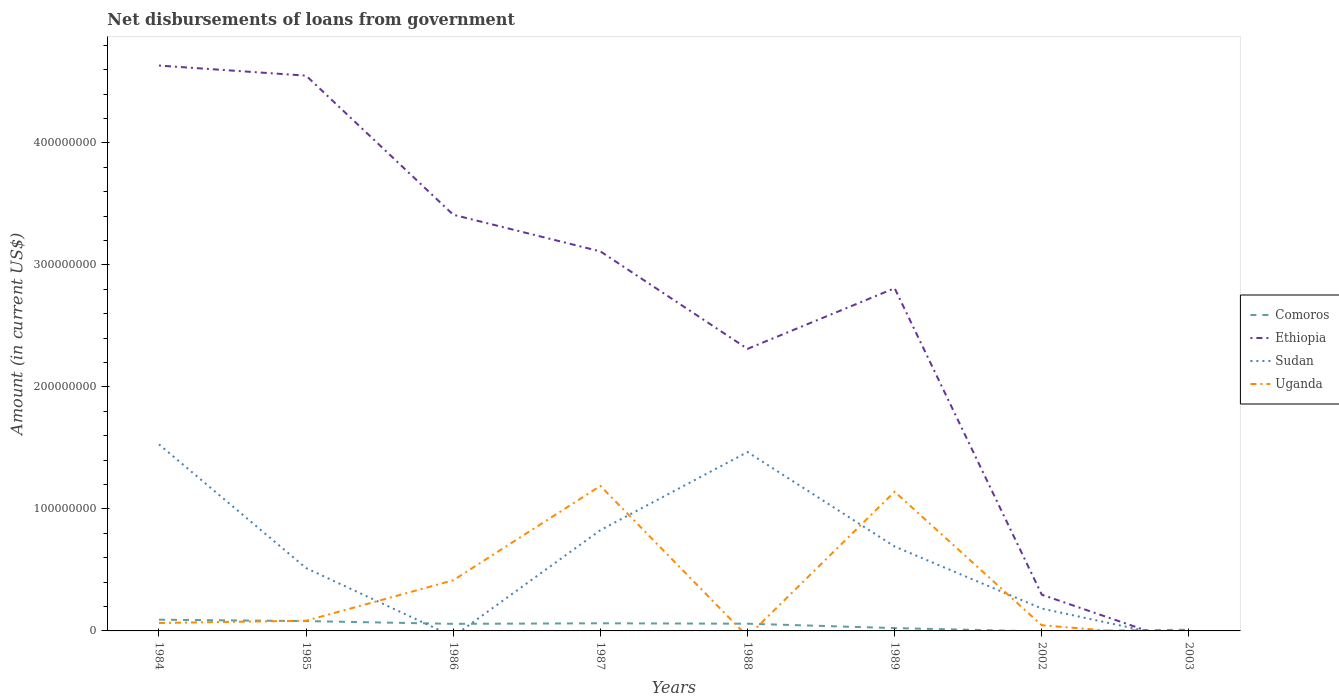Does the line corresponding to Uganda intersect with the line corresponding to Ethiopia?
Offer a terse response. Yes. Across all years, what is the maximum amount of loan disbursed from government in Comoros?
Your answer should be compact. 0. What is the total amount of loan disbursed from government in Ethiopia in the graph?
Offer a terse response. 1.74e+08. What is the difference between the highest and the second highest amount of loan disbursed from government in Comoros?
Provide a succinct answer. 9.22e+06. Is the amount of loan disbursed from government in Sudan strictly greater than the amount of loan disbursed from government in Uganda over the years?
Your response must be concise. No. How many lines are there?
Provide a short and direct response. 4. How are the legend labels stacked?
Your answer should be compact. Vertical. What is the title of the graph?
Provide a short and direct response. Net disbursements of loans from government. Does "Burkina Faso" appear as one of the legend labels in the graph?
Provide a succinct answer. No. What is the label or title of the Y-axis?
Ensure brevity in your answer.  Amount (in current US$). What is the Amount (in current US$) of Comoros in 1984?
Your answer should be compact. 9.22e+06. What is the Amount (in current US$) in Ethiopia in 1984?
Ensure brevity in your answer.  4.63e+08. What is the Amount (in current US$) in Sudan in 1984?
Provide a succinct answer. 1.53e+08. What is the Amount (in current US$) in Uganda in 1984?
Make the answer very short. 6.49e+06. What is the Amount (in current US$) of Comoros in 1985?
Keep it short and to the point. 8.06e+06. What is the Amount (in current US$) in Ethiopia in 1985?
Your answer should be very brief. 4.55e+08. What is the Amount (in current US$) of Sudan in 1985?
Your response must be concise. 5.15e+07. What is the Amount (in current US$) in Uganda in 1985?
Offer a very short reply. 8.37e+06. What is the Amount (in current US$) in Comoros in 1986?
Your response must be concise. 5.80e+06. What is the Amount (in current US$) of Ethiopia in 1986?
Your answer should be compact. 3.41e+08. What is the Amount (in current US$) of Uganda in 1986?
Offer a very short reply. 4.15e+07. What is the Amount (in current US$) of Comoros in 1987?
Your answer should be compact. 6.25e+06. What is the Amount (in current US$) in Ethiopia in 1987?
Offer a terse response. 3.11e+08. What is the Amount (in current US$) in Sudan in 1987?
Your response must be concise. 8.26e+07. What is the Amount (in current US$) in Uganda in 1987?
Provide a succinct answer. 1.19e+08. What is the Amount (in current US$) of Comoros in 1988?
Your response must be concise. 5.91e+06. What is the Amount (in current US$) of Ethiopia in 1988?
Your answer should be compact. 2.31e+08. What is the Amount (in current US$) of Sudan in 1988?
Provide a succinct answer. 1.47e+08. What is the Amount (in current US$) of Uganda in 1988?
Ensure brevity in your answer.  0. What is the Amount (in current US$) in Comoros in 1989?
Your response must be concise. 2.32e+06. What is the Amount (in current US$) of Ethiopia in 1989?
Your answer should be very brief. 2.81e+08. What is the Amount (in current US$) of Sudan in 1989?
Give a very brief answer. 6.92e+07. What is the Amount (in current US$) in Uganda in 1989?
Your answer should be compact. 1.14e+08. What is the Amount (in current US$) in Ethiopia in 2002?
Offer a terse response. 2.97e+07. What is the Amount (in current US$) in Sudan in 2002?
Ensure brevity in your answer.  1.83e+07. What is the Amount (in current US$) of Uganda in 2002?
Offer a very short reply. 4.65e+06. What is the Amount (in current US$) in Comoros in 2003?
Your answer should be very brief. 9.96e+05. What is the Amount (in current US$) of Ethiopia in 2003?
Offer a terse response. 0. What is the Amount (in current US$) of Uganda in 2003?
Provide a succinct answer. 0. Across all years, what is the maximum Amount (in current US$) in Comoros?
Offer a terse response. 9.22e+06. Across all years, what is the maximum Amount (in current US$) of Ethiopia?
Your answer should be very brief. 4.63e+08. Across all years, what is the maximum Amount (in current US$) in Sudan?
Your answer should be compact. 1.53e+08. Across all years, what is the maximum Amount (in current US$) of Uganda?
Make the answer very short. 1.19e+08. Across all years, what is the minimum Amount (in current US$) in Sudan?
Your response must be concise. 0. What is the total Amount (in current US$) in Comoros in the graph?
Offer a very short reply. 3.86e+07. What is the total Amount (in current US$) of Ethiopia in the graph?
Make the answer very short. 2.11e+09. What is the total Amount (in current US$) in Sudan in the graph?
Offer a very short reply. 5.21e+08. What is the total Amount (in current US$) of Uganda in the graph?
Your answer should be compact. 2.94e+08. What is the difference between the Amount (in current US$) of Comoros in 1984 and that in 1985?
Your response must be concise. 1.16e+06. What is the difference between the Amount (in current US$) in Ethiopia in 1984 and that in 1985?
Provide a short and direct response. 8.29e+06. What is the difference between the Amount (in current US$) of Sudan in 1984 and that in 1985?
Give a very brief answer. 1.01e+08. What is the difference between the Amount (in current US$) in Uganda in 1984 and that in 1985?
Your answer should be compact. -1.88e+06. What is the difference between the Amount (in current US$) of Comoros in 1984 and that in 1986?
Ensure brevity in your answer.  3.42e+06. What is the difference between the Amount (in current US$) of Ethiopia in 1984 and that in 1986?
Your answer should be compact. 1.22e+08. What is the difference between the Amount (in current US$) of Uganda in 1984 and that in 1986?
Ensure brevity in your answer.  -3.50e+07. What is the difference between the Amount (in current US$) of Comoros in 1984 and that in 1987?
Offer a very short reply. 2.97e+06. What is the difference between the Amount (in current US$) of Ethiopia in 1984 and that in 1987?
Offer a very short reply. 1.52e+08. What is the difference between the Amount (in current US$) in Sudan in 1984 and that in 1987?
Offer a very short reply. 7.03e+07. What is the difference between the Amount (in current US$) in Uganda in 1984 and that in 1987?
Provide a succinct answer. -1.12e+08. What is the difference between the Amount (in current US$) of Comoros in 1984 and that in 1988?
Your answer should be very brief. 3.30e+06. What is the difference between the Amount (in current US$) in Ethiopia in 1984 and that in 1988?
Give a very brief answer. 2.32e+08. What is the difference between the Amount (in current US$) of Sudan in 1984 and that in 1988?
Make the answer very short. 6.27e+06. What is the difference between the Amount (in current US$) in Comoros in 1984 and that in 1989?
Offer a very short reply. 6.90e+06. What is the difference between the Amount (in current US$) in Ethiopia in 1984 and that in 1989?
Ensure brevity in your answer.  1.83e+08. What is the difference between the Amount (in current US$) of Sudan in 1984 and that in 1989?
Ensure brevity in your answer.  8.37e+07. What is the difference between the Amount (in current US$) of Uganda in 1984 and that in 1989?
Your answer should be compact. -1.08e+08. What is the difference between the Amount (in current US$) of Ethiopia in 1984 and that in 2002?
Your answer should be very brief. 4.34e+08. What is the difference between the Amount (in current US$) in Sudan in 1984 and that in 2002?
Ensure brevity in your answer.  1.35e+08. What is the difference between the Amount (in current US$) of Uganda in 1984 and that in 2002?
Your response must be concise. 1.84e+06. What is the difference between the Amount (in current US$) of Comoros in 1984 and that in 2003?
Keep it short and to the point. 8.22e+06. What is the difference between the Amount (in current US$) in Comoros in 1985 and that in 1986?
Ensure brevity in your answer.  2.26e+06. What is the difference between the Amount (in current US$) of Ethiopia in 1985 and that in 1986?
Give a very brief answer. 1.14e+08. What is the difference between the Amount (in current US$) in Uganda in 1985 and that in 1986?
Give a very brief answer. -3.31e+07. What is the difference between the Amount (in current US$) of Comoros in 1985 and that in 1987?
Provide a succinct answer. 1.80e+06. What is the difference between the Amount (in current US$) of Ethiopia in 1985 and that in 1987?
Offer a terse response. 1.44e+08. What is the difference between the Amount (in current US$) of Sudan in 1985 and that in 1987?
Keep it short and to the point. -3.11e+07. What is the difference between the Amount (in current US$) in Uganda in 1985 and that in 1987?
Give a very brief answer. -1.10e+08. What is the difference between the Amount (in current US$) of Comoros in 1985 and that in 1988?
Keep it short and to the point. 2.14e+06. What is the difference between the Amount (in current US$) in Ethiopia in 1985 and that in 1988?
Provide a short and direct response. 2.24e+08. What is the difference between the Amount (in current US$) in Sudan in 1985 and that in 1988?
Provide a short and direct response. -9.51e+07. What is the difference between the Amount (in current US$) of Comoros in 1985 and that in 1989?
Give a very brief answer. 5.74e+06. What is the difference between the Amount (in current US$) in Ethiopia in 1985 and that in 1989?
Your answer should be compact. 1.74e+08. What is the difference between the Amount (in current US$) in Sudan in 1985 and that in 1989?
Offer a terse response. -1.77e+07. What is the difference between the Amount (in current US$) in Uganda in 1985 and that in 1989?
Provide a succinct answer. -1.06e+08. What is the difference between the Amount (in current US$) in Ethiopia in 1985 and that in 2002?
Give a very brief answer. 4.25e+08. What is the difference between the Amount (in current US$) of Sudan in 1985 and that in 2002?
Your answer should be very brief. 3.32e+07. What is the difference between the Amount (in current US$) in Uganda in 1985 and that in 2002?
Your answer should be very brief. 3.72e+06. What is the difference between the Amount (in current US$) of Comoros in 1985 and that in 2003?
Offer a terse response. 7.06e+06. What is the difference between the Amount (in current US$) of Comoros in 1986 and that in 1987?
Make the answer very short. -4.54e+05. What is the difference between the Amount (in current US$) in Ethiopia in 1986 and that in 1987?
Ensure brevity in your answer.  3.00e+07. What is the difference between the Amount (in current US$) of Uganda in 1986 and that in 1987?
Make the answer very short. -7.73e+07. What is the difference between the Amount (in current US$) in Comoros in 1986 and that in 1988?
Keep it short and to the point. -1.15e+05. What is the difference between the Amount (in current US$) of Ethiopia in 1986 and that in 1988?
Ensure brevity in your answer.  1.10e+08. What is the difference between the Amount (in current US$) of Comoros in 1986 and that in 1989?
Give a very brief answer. 3.48e+06. What is the difference between the Amount (in current US$) of Ethiopia in 1986 and that in 1989?
Provide a succinct answer. 6.02e+07. What is the difference between the Amount (in current US$) of Uganda in 1986 and that in 1989?
Ensure brevity in your answer.  -7.26e+07. What is the difference between the Amount (in current US$) in Ethiopia in 1986 and that in 2002?
Keep it short and to the point. 3.11e+08. What is the difference between the Amount (in current US$) of Uganda in 1986 and that in 2002?
Your answer should be compact. 3.69e+07. What is the difference between the Amount (in current US$) of Comoros in 1986 and that in 2003?
Provide a short and direct response. 4.80e+06. What is the difference between the Amount (in current US$) of Comoros in 1987 and that in 1988?
Your response must be concise. 3.39e+05. What is the difference between the Amount (in current US$) in Ethiopia in 1987 and that in 1988?
Your response must be concise. 7.99e+07. What is the difference between the Amount (in current US$) in Sudan in 1987 and that in 1988?
Keep it short and to the point. -6.40e+07. What is the difference between the Amount (in current US$) of Comoros in 1987 and that in 1989?
Keep it short and to the point. 3.93e+06. What is the difference between the Amount (in current US$) in Ethiopia in 1987 and that in 1989?
Your response must be concise. 3.02e+07. What is the difference between the Amount (in current US$) in Sudan in 1987 and that in 1989?
Make the answer very short. 1.34e+07. What is the difference between the Amount (in current US$) in Uganda in 1987 and that in 1989?
Offer a very short reply. 4.75e+06. What is the difference between the Amount (in current US$) in Ethiopia in 1987 and that in 2002?
Ensure brevity in your answer.  2.81e+08. What is the difference between the Amount (in current US$) in Sudan in 1987 and that in 2002?
Offer a very short reply. 6.43e+07. What is the difference between the Amount (in current US$) in Uganda in 1987 and that in 2002?
Offer a terse response. 1.14e+08. What is the difference between the Amount (in current US$) of Comoros in 1987 and that in 2003?
Offer a very short reply. 5.26e+06. What is the difference between the Amount (in current US$) in Comoros in 1988 and that in 1989?
Keep it short and to the point. 3.59e+06. What is the difference between the Amount (in current US$) of Ethiopia in 1988 and that in 1989?
Provide a succinct answer. -4.97e+07. What is the difference between the Amount (in current US$) in Sudan in 1988 and that in 1989?
Ensure brevity in your answer.  7.74e+07. What is the difference between the Amount (in current US$) of Ethiopia in 1988 and that in 2002?
Your response must be concise. 2.02e+08. What is the difference between the Amount (in current US$) of Sudan in 1988 and that in 2002?
Keep it short and to the point. 1.28e+08. What is the difference between the Amount (in current US$) of Comoros in 1988 and that in 2003?
Keep it short and to the point. 4.92e+06. What is the difference between the Amount (in current US$) of Ethiopia in 1989 and that in 2002?
Make the answer very short. 2.51e+08. What is the difference between the Amount (in current US$) in Sudan in 1989 and that in 2002?
Give a very brief answer. 5.08e+07. What is the difference between the Amount (in current US$) in Uganda in 1989 and that in 2002?
Offer a terse response. 1.09e+08. What is the difference between the Amount (in current US$) in Comoros in 1989 and that in 2003?
Your answer should be very brief. 1.32e+06. What is the difference between the Amount (in current US$) of Comoros in 1984 and the Amount (in current US$) of Ethiopia in 1985?
Keep it short and to the point. -4.46e+08. What is the difference between the Amount (in current US$) in Comoros in 1984 and the Amount (in current US$) in Sudan in 1985?
Ensure brevity in your answer.  -4.23e+07. What is the difference between the Amount (in current US$) of Comoros in 1984 and the Amount (in current US$) of Uganda in 1985?
Offer a very short reply. 8.48e+05. What is the difference between the Amount (in current US$) in Ethiopia in 1984 and the Amount (in current US$) in Sudan in 1985?
Your answer should be very brief. 4.12e+08. What is the difference between the Amount (in current US$) of Ethiopia in 1984 and the Amount (in current US$) of Uganda in 1985?
Your response must be concise. 4.55e+08. What is the difference between the Amount (in current US$) in Sudan in 1984 and the Amount (in current US$) in Uganda in 1985?
Provide a short and direct response. 1.45e+08. What is the difference between the Amount (in current US$) of Comoros in 1984 and the Amount (in current US$) of Ethiopia in 1986?
Provide a short and direct response. -3.32e+08. What is the difference between the Amount (in current US$) in Comoros in 1984 and the Amount (in current US$) in Uganda in 1986?
Provide a short and direct response. -3.23e+07. What is the difference between the Amount (in current US$) in Ethiopia in 1984 and the Amount (in current US$) in Uganda in 1986?
Your answer should be compact. 4.22e+08. What is the difference between the Amount (in current US$) in Sudan in 1984 and the Amount (in current US$) in Uganda in 1986?
Offer a terse response. 1.11e+08. What is the difference between the Amount (in current US$) of Comoros in 1984 and the Amount (in current US$) of Ethiopia in 1987?
Keep it short and to the point. -3.02e+08. What is the difference between the Amount (in current US$) of Comoros in 1984 and the Amount (in current US$) of Sudan in 1987?
Your answer should be compact. -7.34e+07. What is the difference between the Amount (in current US$) of Comoros in 1984 and the Amount (in current US$) of Uganda in 1987?
Give a very brief answer. -1.10e+08. What is the difference between the Amount (in current US$) in Ethiopia in 1984 and the Amount (in current US$) in Sudan in 1987?
Offer a very short reply. 3.81e+08. What is the difference between the Amount (in current US$) of Ethiopia in 1984 and the Amount (in current US$) of Uganda in 1987?
Offer a terse response. 3.45e+08. What is the difference between the Amount (in current US$) in Sudan in 1984 and the Amount (in current US$) in Uganda in 1987?
Your answer should be compact. 3.41e+07. What is the difference between the Amount (in current US$) in Comoros in 1984 and the Amount (in current US$) in Ethiopia in 1988?
Offer a very short reply. -2.22e+08. What is the difference between the Amount (in current US$) in Comoros in 1984 and the Amount (in current US$) in Sudan in 1988?
Your answer should be very brief. -1.37e+08. What is the difference between the Amount (in current US$) of Ethiopia in 1984 and the Amount (in current US$) of Sudan in 1988?
Keep it short and to the point. 3.17e+08. What is the difference between the Amount (in current US$) of Comoros in 1984 and the Amount (in current US$) of Ethiopia in 1989?
Give a very brief answer. -2.72e+08. What is the difference between the Amount (in current US$) in Comoros in 1984 and the Amount (in current US$) in Sudan in 1989?
Provide a short and direct response. -6.00e+07. What is the difference between the Amount (in current US$) of Comoros in 1984 and the Amount (in current US$) of Uganda in 1989?
Your answer should be very brief. -1.05e+08. What is the difference between the Amount (in current US$) of Ethiopia in 1984 and the Amount (in current US$) of Sudan in 1989?
Keep it short and to the point. 3.94e+08. What is the difference between the Amount (in current US$) of Ethiopia in 1984 and the Amount (in current US$) of Uganda in 1989?
Make the answer very short. 3.49e+08. What is the difference between the Amount (in current US$) of Sudan in 1984 and the Amount (in current US$) of Uganda in 1989?
Provide a succinct answer. 3.88e+07. What is the difference between the Amount (in current US$) of Comoros in 1984 and the Amount (in current US$) of Ethiopia in 2002?
Provide a succinct answer. -2.05e+07. What is the difference between the Amount (in current US$) in Comoros in 1984 and the Amount (in current US$) in Sudan in 2002?
Keep it short and to the point. -9.11e+06. What is the difference between the Amount (in current US$) in Comoros in 1984 and the Amount (in current US$) in Uganda in 2002?
Offer a very short reply. 4.57e+06. What is the difference between the Amount (in current US$) of Ethiopia in 1984 and the Amount (in current US$) of Sudan in 2002?
Provide a short and direct response. 4.45e+08. What is the difference between the Amount (in current US$) in Ethiopia in 1984 and the Amount (in current US$) in Uganda in 2002?
Offer a very short reply. 4.59e+08. What is the difference between the Amount (in current US$) of Sudan in 1984 and the Amount (in current US$) of Uganda in 2002?
Offer a very short reply. 1.48e+08. What is the difference between the Amount (in current US$) of Comoros in 1985 and the Amount (in current US$) of Ethiopia in 1986?
Offer a terse response. -3.33e+08. What is the difference between the Amount (in current US$) of Comoros in 1985 and the Amount (in current US$) of Uganda in 1986?
Your answer should be very brief. -3.35e+07. What is the difference between the Amount (in current US$) in Ethiopia in 1985 and the Amount (in current US$) in Uganda in 1986?
Make the answer very short. 4.14e+08. What is the difference between the Amount (in current US$) in Sudan in 1985 and the Amount (in current US$) in Uganda in 1986?
Offer a very short reply. 9.98e+06. What is the difference between the Amount (in current US$) in Comoros in 1985 and the Amount (in current US$) in Ethiopia in 1987?
Offer a terse response. -3.03e+08. What is the difference between the Amount (in current US$) of Comoros in 1985 and the Amount (in current US$) of Sudan in 1987?
Offer a terse response. -7.45e+07. What is the difference between the Amount (in current US$) of Comoros in 1985 and the Amount (in current US$) of Uganda in 1987?
Ensure brevity in your answer.  -1.11e+08. What is the difference between the Amount (in current US$) in Ethiopia in 1985 and the Amount (in current US$) in Sudan in 1987?
Ensure brevity in your answer.  3.73e+08. What is the difference between the Amount (in current US$) of Ethiopia in 1985 and the Amount (in current US$) of Uganda in 1987?
Your answer should be compact. 3.36e+08. What is the difference between the Amount (in current US$) in Sudan in 1985 and the Amount (in current US$) in Uganda in 1987?
Offer a very short reply. -6.73e+07. What is the difference between the Amount (in current US$) in Comoros in 1985 and the Amount (in current US$) in Ethiopia in 1988?
Your response must be concise. -2.23e+08. What is the difference between the Amount (in current US$) of Comoros in 1985 and the Amount (in current US$) of Sudan in 1988?
Provide a short and direct response. -1.39e+08. What is the difference between the Amount (in current US$) in Ethiopia in 1985 and the Amount (in current US$) in Sudan in 1988?
Your answer should be very brief. 3.08e+08. What is the difference between the Amount (in current US$) of Comoros in 1985 and the Amount (in current US$) of Ethiopia in 1989?
Make the answer very short. -2.73e+08. What is the difference between the Amount (in current US$) in Comoros in 1985 and the Amount (in current US$) in Sudan in 1989?
Offer a terse response. -6.11e+07. What is the difference between the Amount (in current US$) of Comoros in 1985 and the Amount (in current US$) of Uganda in 1989?
Keep it short and to the point. -1.06e+08. What is the difference between the Amount (in current US$) in Ethiopia in 1985 and the Amount (in current US$) in Sudan in 1989?
Offer a terse response. 3.86e+08. What is the difference between the Amount (in current US$) in Ethiopia in 1985 and the Amount (in current US$) in Uganda in 1989?
Ensure brevity in your answer.  3.41e+08. What is the difference between the Amount (in current US$) in Sudan in 1985 and the Amount (in current US$) in Uganda in 1989?
Provide a short and direct response. -6.26e+07. What is the difference between the Amount (in current US$) in Comoros in 1985 and the Amount (in current US$) in Ethiopia in 2002?
Make the answer very short. -2.16e+07. What is the difference between the Amount (in current US$) in Comoros in 1985 and the Amount (in current US$) in Sudan in 2002?
Provide a short and direct response. -1.03e+07. What is the difference between the Amount (in current US$) of Comoros in 1985 and the Amount (in current US$) of Uganda in 2002?
Your answer should be very brief. 3.41e+06. What is the difference between the Amount (in current US$) in Ethiopia in 1985 and the Amount (in current US$) in Sudan in 2002?
Your response must be concise. 4.37e+08. What is the difference between the Amount (in current US$) in Ethiopia in 1985 and the Amount (in current US$) in Uganda in 2002?
Make the answer very short. 4.50e+08. What is the difference between the Amount (in current US$) of Sudan in 1985 and the Amount (in current US$) of Uganda in 2002?
Offer a very short reply. 4.68e+07. What is the difference between the Amount (in current US$) in Comoros in 1986 and the Amount (in current US$) in Ethiopia in 1987?
Your response must be concise. -3.05e+08. What is the difference between the Amount (in current US$) in Comoros in 1986 and the Amount (in current US$) in Sudan in 1987?
Your answer should be very brief. -7.68e+07. What is the difference between the Amount (in current US$) in Comoros in 1986 and the Amount (in current US$) in Uganda in 1987?
Provide a short and direct response. -1.13e+08. What is the difference between the Amount (in current US$) in Ethiopia in 1986 and the Amount (in current US$) in Sudan in 1987?
Your response must be concise. 2.59e+08. What is the difference between the Amount (in current US$) in Ethiopia in 1986 and the Amount (in current US$) in Uganda in 1987?
Make the answer very short. 2.22e+08. What is the difference between the Amount (in current US$) of Comoros in 1986 and the Amount (in current US$) of Ethiopia in 1988?
Give a very brief answer. -2.25e+08. What is the difference between the Amount (in current US$) of Comoros in 1986 and the Amount (in current US$) of Sudan in 1988?
Your response must be concise. -1.41e+08. What is the difference between the Amount (in current US$) of Ethiopia in 1986 and the Amount (in current US$) of Sudan in 1988?
Offer a terse response. 1.94e+08. What is the difference between the Amount (in current US$) of Comoros in 1986 and the Amount (in current US$) of Ethiopia in 1989?
Your answer should be very brief. -2.75e+08. What is the difference between the Amount (in current US$) in Comoros in 1986 and the Amount (in current US$) in Sudan in 1989?
Make the answer very short. -6.34e+07. What is the difference between the Amount (in current US$) in Comoros in 1986 and the Amount (in current US$) in Uganda in 1989?
Keep it short and to the point. -1.08e+08. What is the difference between the Amount (in current US$) of Ethiopia in 1986 and the Amount (in current US$) of Sudan in 1989?
Make the answer very short. 2.72e+08. What is the difference between the Amount (in current US$) in Ethiopia in 1986 and the Amount (in current US$) in Uganda in 1989?
Your answer should be very brief. 2.27e+08. What is the difference between the Amount (in current US$) in Comoros in 1986 and the Amount (in current US$) in Ethiopia in 2002?
Your answer should be very brief. -2.39e+07. What is the difference between the Amount (in current US$) of Comoros in 1986 and the Amount (in current US$) of Sudan in 2002?
Keep it short and to the point. -1.25e+07. What is the difference between the Amount (in current US$) of Comoros in 1986 and the Amount (in current US$) of Uganda in 2002?
Offer a terse response. 1.15e+06. What is the difference between the Amount (in current US$) in Ethiopia in 1986 and the Amount (in current US$) in Sudan in 2002?
Keep it short and to the point. 3.23e+08. What is the difference between the Amount (in current US$) in Ethiopia in 1986 and the Amount (in current US$) in Uganda in 2002?
Your response must be concise. 3.36e+08. What is the difference between the Amount (in current US$) in Comoros in 1987 and the Amount (in current US$) in Ethiopia in 1988?
Your answer should be compact. -2.25e+08. What is the difference between the Amount (in current US$) of Comoros in 1987 and the Amount (in current US$) of Sudan in 1988?
Provide a succinct answer. -1.40e+08. What is the difference between the Amount (in current US$) in Ethiopia in 1987 and the Amount (in current US$) in Sudan in 1988?
Your answer should be very brief. 1.64e+08. What is the difference between the Amount (in current US$) of Comoros in 1987 and the Amount (in current US$) of Ethiopia in 1989?
Your answer should be very brief. -2.75e+08. What is the difference between the Amount (in current US$) in Comoros in 1987 and the Amount (in current US$) in Sudan in 1989?
Ensure brevity in your answer.  -6.29e+07. What is the difference between the Amount (in current US$) in Comoros in 1987 and the Amount (in current US$) in Uganda in 1989?
Offer a terse response. -1.08e+08. What is the difference between the Amount (in current US$) in Ethiopia in 1987 and the Amount (in current US$) in Sudan in 1989?
Your answer should be compact. 2.42e+08. What is the difference between the Amount (in current US$) of Ethiopia in 1987 and the Amount (in current US$) of Uganda in 1989?
Your answer should be compact. 1.97e+08. What is the difference between the Amount (in current US$) in Sudan in 1987 and the Amount (in current US$) in Uganda in 1989?
Your response must be concise. -3.15e+07. What is the difference between the Amount (in current US$) of Comoros in 1987 and the Amount (in current US$) of Ethiopia in 2002?
Your answer should be very brief. -2.34e+07. What is the difference between the Amount (in current US$) in Comoros in 1987 and the Amount (in current US$) in Sudan in 2002?
Make the answer very short. -1.21e+07. What is the difference between the Amount (in current US$) in Comoros in 1987 and the Amount (in current US$) in Uganda in 2002?
Give a very brief answer. 1.60e+06. What is the difference between the Amount (in current US$) in Ethiopia in 1987 and the Amount (in current US$) in Sudan in 2002?
Offer a very short reply. 2.93e+08. What is the difference between the Amount (in current US$) in Ethiopia in 1987 and the Amount (in current US$) in Uganda in 2002?
Make the answer very short. 3.06e+08. What is the difference between the Amount (in current US$) in Sudan in 1987 and the Amount (in current US$) in Uganda in 2002?
Your answer should be very brief. 7.79e+07. What is the difference between the Amount (in current US$) in Comoros in 1988 and the Amount (in current US$) in Ethiopia in 1989?
Make the answer very short. -2.75e+08. What is the difference between the Amount (in current US$) of Comoros in 1988 and the Amount (in current US$) of Sudan in 1989?
Keep it short and to the point. -6.33e+07. What is the difference between the Amount (in current US$) in Comoros in 1988 and the Amount (in current US$) in Uganda in 1989?
Provide a short and direct response. -1.08e+08. What is the difference between the Amount (in current US$) in Ethiopia in 1988 and the Amount (in current US$) in Sudan in 1989?
Provide a short and direct response. 1.62e+08. What is the difference between the Amount (in current US$) of Ethiopia in 1988 and the Amount (in current US$) of Uganda in 1989?
Keep it short and to the point. 1.17e+08. What is the difference between the Amount (in current US$) of Sudan in 1988 and the Amount (in current US$) of Uganda in 1989?
Keep it short and to the point. 3.25e+07. What is the difference between the Amount (in current US$) of Comoros in 1988 and the Amount (in current US$) of Ethiopia in 2002?
Give a very brief answer. -2.38e+07. What is the difference between the Amount (in current US$) of Comoros in 1988 and the Amount (in current US$) of Sudan in 2002?
Keep it short and to the point. -1.24e+07. What is the difference between the Amount (in current US$) of Comoros in 1988 and the Amount (in current US$) of Uganda in 2002?
Give a very brief answer. 1.26e+06. What is the difference between the Amount (in current US$) of Ethiopia in 1988 and the Amount (in current US$) of Sudan in 2002?
Your answer should be compact. 2.13e+08. What is the difference between the Amount (in current US$) in Ethiopia in 1988 and the Amount (in current US$) in Uganda in 2002?
Your answer should be very brief. 2.27e+08. What is the difference between the Amount (in current US$) in Sudan in 1988 and the Amount (in current US$) in Uganda in 2002?
Ensure brevity in your answer.  1.42e+08. What is the difference between the Amount (in current US$) in Comoros in 1989 and the Amount (in current US$) in Ethiopia in 2002?
Offer a terse response. -2.74e+07. What is the difference between the Amount (in current US$) in Comoros in 1989 and the Amount (in current US$) in Sudan in 2002?
Your answer should be very brief. -1.60e+07. What is the difference between the Amount (in current US$) in Comoros in 1989 and the Amount (in current US$) in Uganda in 2002?
Give a very brief answer. -2.33e+06. What is the difference between the Amount (in current US$) in Ethiopia in 1989 and the Amount (in current US$) in Sudan in 2002?
Offer a terse response. 2.63e+08. What is the difference between the Amount (in current US$) in Ethiopia in 1989 and the Amount (in current US$) in Uganda in 2002?
Keep it short and to the point. 2.76e+08. What is the difference between the Amount (in current US$) of Sudan in 1989 and the Amount (in current US$) of Uganda in 2002?
Keep it short and to the point. 6.45e+07. What is the average Amount (in current US$) in Comoros per year?
Offer a very short reply. 4.82e+06. What is the average Amount (in current US$) of Ethiopia per year?
Keep it short and to the point. 2.64e+08. What is the average Amount (in current US$) in Sudan per year?
Make the answer very short. 6.51e+07. What is the average Amount (in current US$) of Uganda per year?
Provide a succinct answer. 3.67e+07. In the year 1984, what is the difference between the Amount (in current US$) in Comoros and Amount (in current US$) in Ethiopia?
Provide a short and direct response. -4.54e+08. In the year 1984, what is the difference between the Amount (in current US$) in Comoros and Amount (in current US$) in Sudan?
Give a very brief answer. -1.44e+08. In the year 1984, what is the difference between the Amount (in current US$) in Comoros and Amount (in current US$) in Uganda?
Offer a very short reply. 2.73e+06. In the year 1984, what is the difference between the Amount (in current US$) of Ethiopia and Amount (in current US$) of Sudan?
Give a very brief answer. 3.10e+08. In the year 1984, what is the difference between the Amount (in current US$) of Ethiopia and Amount (in current US$) of Uganda?
Keep it short and to the point. 4.57e+08. In the year 1984, what is the difference between the Amount (in current US$) of Sudan and Amount (in current US$) of Uganda?
Provide a short and direct response. 1.46e+08. In the year 1985, what is the difference between the Amount (in current US$) in Comoros and Amount (in current US$) in Ethiopia?
Your response must be concise. -4.47e+08. In the year 1985, what is the difference between the Amount (in current US$) in Comoros and Amount (in current US$) in Sudan?
Offer a very short reply. -4.34e+07. In the year 1985, what is the difference between the Amount (in current US$) in Comoros and Amount (in current US$) in Uganda?
Offer a terse response. -3.14e+05. In the year 1985, what is the difference between the Amount (in current US$) of Ethiopia and Amount (in current US$) of Sudan?
Your response must be concise. 4.04e+08. In the year 1985, what is the difference between the Amount (in current US$) of Ethiopia and Amount (in current US$) of Uganda?
Make the answer very short. 4.47e+08. In the year 1985, what is the difference between the Amount (in current US$) of Sudan and Amount (in current US$) of Uganda?
Your answer should be compact. 4.31e+07. In the year 1986, what is the difference between the Amount (in current US$) of Comoros and Amount (in current US$) of Ethiopia?
Provide a succinct answer. -3.35e+08. In the year 1986, what is the difference between the Amount (in current US$) of Comoros and Amount (in current US$) of Uganda?
Your response must be concise. -3.57e+07. In the year 1986, what is the difference between the Amount (in current US$) in Ethiopia and Amount (in current US$) in Uganda?
Make the answer very short. 3.00e+08. In the year 1987, what is the difference between the Amount (in current US$) of Comoros and Amount (in current US$) of Ethiopia?
Keep it short and to the point. -3.05e+08. In the year 1987, what is the difference between the Amount (in current US$) in Comoros and Amount (in current US$) in Sudan?
Provide a succinct answer. -7.63e+07. In the year 1987, what is the difference between the Amount (in current US$) of Comoros and Amount (in current US$) of Uganda?
Provide a short and direct response. -1.13e+08. In the year 1987, what is the difference between the Amount (in current US$) of Ethiopia and Amount (in current US$) of Sudan?
Offer a terse response. 2.28e+08. In the year 1987, what is the difference between the Amount (in current US$) in Ethiopia and Amount (in current US$) in Uganda?
Ensure brevity in your answer.  1.92e+08. In the year 1987, what is the difference between the Amount (in current US$) in Sudan and Amount (in current US$) in Uganda?
Give a very brief answer. -3.62e+07. In the year 1988, what is the difference between the Amount (in current US$) of Comoros and Amount (in current US$) of Ethiopia?
Keep it short and to the point. -2.25e+08. In the year 1988, what is the difference between the Amount (in current US$) in Comoros and Amount (in current US$) in Sudan?
Ensure brevity in your answer.  -1.41e+08. In the year 1988, what is the difference between the Amount (in current US$) in Ethiopia and Amount (in current US$) in Sudan?
Your answer should be very brief. 8.46e+07. In the year 1989, what is the difference between the Amount (in current US$) of Comoros and Amount (in current US$) of Ethiopia?
Offer a very short reply. -2.79e+08. In the year 1989, what is the difference between the Amount (in current US$) of Comoros and Amount (in current US$) of Sudan?
Offer a terse response. -6.69e+07. In the year 1989, what is the difference between the Amount (in current US$) of Comoros and Amount (in current US$) of Uganda?
Offer a very short reply. -1.12e+08. In the year 1989, what is the difference between the Amount (in current US$) of Ethiopia and Amount (in current US$) of Sudan?
Keep it short and to the point. 2.12e+08. In the year 1989, what is the difference between the Amount (in current US$) in Ethiopia and Amount (in current US$) in Uganda?
Give a very brief answer. 1.67e+08. In the year 1989, what is the difference between the Amount (in current US$) in Sudan and Amount (in current US$) in Uganda?
Offer a terse response. -4.49e+07. In the year 2002, what is the difference between the Amount (in current US$) in Ethiopia and Amount (in current US$) in Sudan?
Your answer should be very brief. 1.14e+07. In the year 2002, what is the difference between the Amount (in current US$) in Ethiopia and Amount (in current US$) in Uganda?
Your response must be concise. 2.50e+07. In the year 2002, what is the difference between the Amount (in current US$) in Sudan and Amount (in current US$) in Uganda?
Your answer should be very brief. 1.37e+07. What is the ratio of the Amount (in current US$) of Comoros in 1984 to that in 1985?
Make the answer very short. 1.14. What is the ratio of the Amount (in current US$) of Ethiopia in 1984 to that in 1985?
Ensure brevity in your answer.  1.02. What is the ratio of the Amount (in current US$) of Sudan in 1984 to that in 1985?
Keep it short and to the point. 2.97. What is the ratio of the Amount (in current US$) in Uganda in 1984 to that in 1985?
Provide a short and direct response. 0.78. What is the ratio of the Amount (in current US$) in Comoros in 1984 to that in 1986?
Offer a terse response. 1.59. What is the ratio of the Amount (in current US$) of Ethiopia in 1984 to that in 1986?
Provide a short and direct response. 1.36. What is the ratio of the Amount (in current US$) in Uganda in 1984 to that in 1986?
Your answer should be compact. 0.16. What is the ratio of the Amount (in current US$) of Comoros in 1984 to that in 1987?
Offer a terse response. 1.47. What is the ratio of the Amount (in current US$) in Ethiopia in 1984 to that in 1987?
Offer a very short reply. 1.49. What is the ratio of the Amount (in current US$) of Sudan in 1984 to that in 1987?
Your response must be concise. 1.85. What is the ratio of the Amount (in current US$) in Uganda in 1984 to that in 1987?
Keep it short and to the point. 0.05. What is the ratio of the Amount (in current US$) in Comoros in 1984 to that in 1988?
Provide a short and direct response. 1.56. What is the ratio of the Amount (in current US$) in Ethiopia in 1984 to that in 1988?
Give a very brief answer. 2. What is the ratio of the Amount (in current US$) in Sudan in 1984 to that in 1988?
Provide a succinct answer. 1.04. What is the ratio of the Amount (in current US$) of Comoros in 1984 to that in 1989?
Offer a very short reply. 3.98. What is the ratio of the Amount (in current US$) of Ethiopia in 1984 to that in 1989?
Keep it short and to the point. 1.65. What is the ratio of the Amount (in current US$) in Sudan in 1984 to that in 1989?
Make the answer very short. 2.21. What is the ratio of the Amount (in current US$) of Uganda in 1984 to that in 1989?
Provide a short and direct response. 0.06. What is the ratio of the Amount (in current US$) of Ethiopia in 1984 to that in 2002?
Make the answer very short. 15.61. What is the ratio of the Amount (in current US$) of Sudan in 1984 to that in 2002?
Offer a very short reply. 8.34. What is the ratio of the Amount (in current US$) of Uganda in 1984 to that in 2002?
Ensure brevity in your answer.  1.4. What is the ratio of the Amount (in current US$) of Comoros in 1984 to that in 2003?
Provide a short and direct response. 9.26. What is the ratio of the Amount (in current US$) of Comoros in 1985 to that in 1986?
Keep it short and to the point. 1.39. What is the ratio of the Amount (in current US$) of Ethiopia in 1985 to that in 1986?
Provide a short and direct response. 1.33. What is the ratio of the Amount (in current US$) in Uganda in 1985 to that in 1986?
Your answer should be very brief. 0.2. What is the ratio of the Amount (in current US$) of Comoros in 1985 to that in 1987?
Your answer should be very brief. 1.29. What is the ratio of the Amount (in current US$) of Ethiopia in 1985 to that in 1987?
Give a very brief answer. 1.46. What is the ratio of the Amount (in current US$) in Sudan in 1985 to that in 1987?
Provide a succinct answer. 0.62. What is the ratio of the Amount (in current US$) in Uganda in 1985 to that in 1987?
Ensure brevity in your answer.  0.07. What is the ratio of the Amount (in current US$) in Comoros in 1985 to that in 1988?
Provide a succinct answer. 1.36. What is the ratio of the Amount (in current US$) of Ethiopia in 1985 to that in 1988?
Ensure brevity in your answer.  1.97. What is the ratio of the Amount (in current US$) in Sudan in 1985 to that in 1988?
Offer a very short reply. 0.35. What is the ratio of the Amount (in current US$) in Comoros in 1985 to that in 1989?
Offer a very short reply. 3.47. What is the ratio of the Amount (in current US$) in Ethiopia in 1985 to that in 1989?
Your response must be concise. 1.62. What is the ratio of the Amount (in current US$) in Sudan in 1985 to that in 1989?
Your response must be concise. 0.74. What is the ratio of the Amount (in current US$) in Uganda in 1985 to that in 1989?
Ensure brevity in your answer.  0.07. What is the ratio of the Amount (in current US$) in Ethiopia in 1985 to that in 2002?
Ensure brevity in your answer.  15.33. What is the ratio of the Amount (in current US$) of Sudan in 1985 to that in 2002?
Ensure brevity in your answer.  2.81. What is the ratio of the Amount (in current US$) in Comoros in 1985 to that in 2003?
Give a very brief answer. 8.09. What is the ratio of the Amount (in current US$) of Comoros in 1986 to that in 1987?
Provide a short and direct response. 0.93. What is the ratio of the Amount (in current US$) of Ethiopia in 1986 to that in 1987?
Your answer should be compact. 1.1. What is the ratio of the Amount (in current US$) of Uganda in 1986 to that in 1987?
Your answer should be compact. 0.35. What is the ratio of the Amount (in current US$) in Comoros in 1986 to that in 1988?
Provide a short and direct response. 0.98. What is the ratio of the Amount (in current US$) in Ethiopia in 1986 to that in 1988?
Make the answer very short. 1.48. What is the ratio of the Amount (in current US$) of Comoros in 1986 to that in 1989?
Ensure brevity in your answer.  2.5. What is the ratio of the Amount (in current US$) in Ethiopia in 1986 to that in 1989?
Make the answer very short. 1.21. What is the ratio of the Amount (in current US$) of Uganda in 1986 to that in 1989?
Make the answer very short. 0.36. What is the ratio of the Amount (in current US$) of Ethiopia in 1986 to that in 2002?
Your answer should be very brief. 11.49. What is the ratio of the Amount (in current US$) in Uganda in 1986 to that in 2002?
Provide a short and direct response. 8.93. What is the ratio of the Amount (in current US$) in Comoros in 1986 to that in 2003?
Make the answer very short. 5.82. What is the ratio of the Amount (in current US$) in Comoros in 1987 to that in 1988?
Your response must be concise. 1.06. What is the ratio of the Amount (in current US$) of Ethiopia in 1987 to that in 1988?
Provide a succinct answer. 1.35. What is the ratio of the Amount (in current US$) of Sudan in 1987 to that in 1988?
Your answer should be very brief. 0.56. What is the ratio of the Amount (in current US$) in Comoros in 1987 to that in 1989?
Make the answer very short. 2.7. What is the ratio of the Amount (in current US$) of Ethiopia in 1987 to that in 1989?
Your response must be concise. 1.11. What is the ratio of the Amount (in current US$) in Sudan in 1987 to that in 1989?
Make the answer very short. 1.19. What is the ratio of the Amount (in current US$) of Uganda in 1987 to that in 1989?
Your answer should be very brief. 1.04. What is the ratio of the Amount (in current US$) of Ethiopia in 1987 to that in 2002?
Your answer should be very brief. 10.48. What is the ratio of the Amount (in current US$) of Sudan in 1987 to that in 2002?
Keep it short and to the point. 4.51. What is the ratio of the Amount (in current US$) in Uganda in 1987 to that in 2002?
Keep it short and to the point. 25.56. What is the ratio of the Amount (in current US$) in Comoros in 1987 to that in 2003?
Provide a short and direct response. 6.28. What is the ratio of the Amount (in current US$) in Comoros in 1988 to that in 1989?
Provide a short and direct response. 2.55. What is the ratio of the Amount (in current US$) in Ethiopia in 1988 to that in 1989?
Give a very brief answer. 0.82. What is the ratio of the Amount (in current US$) of Sudan in 1988 to that in 1989?
Offer a very short reply. 2.12. What is the ratio of the Amount (in current US$) in Ethiopia in 1988 to that in 2002?
Make the answer very short. 7.79. What is the ratio of the Amount (in current US$) of Sudan in 1988 to that in 2002?
Provide a short and direct response. 8. What is the ratio of the Amount (in current US$) of Comoros in 1988 to that in 2003?
Ensure brevity in your answer.  5.94. What is the ratio of the Amount (in current US$) of Ethiopia in 1989 to that in 2002?
Your response must be concise. 9.46. What is the ratio of the Amount (in current US$) in Sudan in 1989 to that in 2002?
Provide a short and direct response. 3.77. What is the ratio of the Amount (in current US$) in Uganda in 1989 to that in 2002?
Your answer should be very brief. 24.53. What is the ratio of the Amount (in current US$) of Comoros in 1989 to that in 2003?
Give a very brief answer. 2.33. What is the difference between the highest and the second highest Amount (in current US$) in Comoros?
Offer a terse response. 1.16e+06. What is the difference between the highest and the second highest Amount (in current US$) in Ethiopia?
Your answer should be very brief. 8.29e+06. What is the difference between the highest and the second highest Amount (in current US$) of Sudan?
Your answer should be compact. 6.27e+06. What is the difference between the highest and the second highest Amount (in current US$) in Uganda?
Offer a very short reply. 4.75e+06. What is the difference between the highest and the lowest Amount (in current US$) of Comoros?
Give a very brief answer. 9.22e+06. What is the difference between the highest and the lowest Amount (in current US$) of Ethiopia?
Ensure brevity in your answer.  4.63e+08. What is the difference between the highest and the lowest Amount (in current US$) in Sudan?
Your response must be concise. 1.53e+08. What is the difference between the highest and the lowest Amount (in current US$) of Uganda?
Make the answer very short. 1.19e+08. 